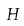Convert formula to latex. <formula><loc_0><loc_0><loc_500><loc_500>H</formula> 